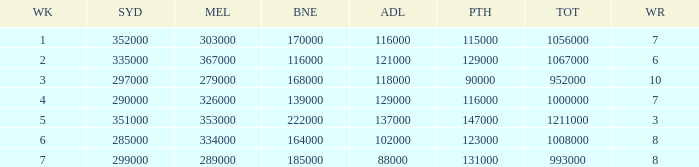How many viewers were there in Sydney for the episode when there were 334000 in Melbourne? 285000.0. 